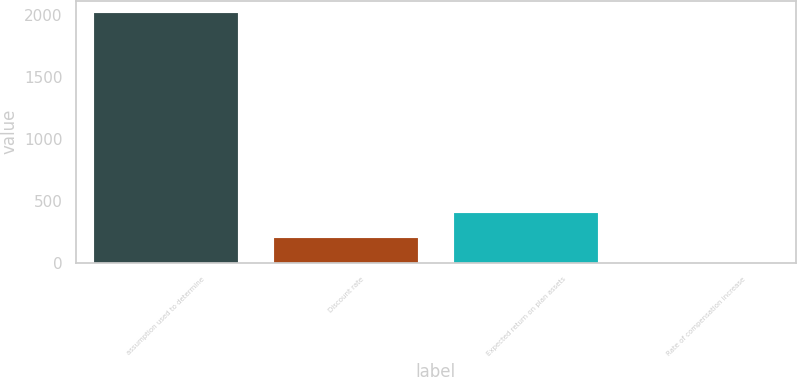Convert chart. <chart><loc_0><loc_0><loc_500><loc_500><bar_chart><fcel>assumption used to determine<fcel>Discount rate<fcel>Expected return on plan assets<fcel>Rate of compensation increase<nl><fcel>2015<fcel>203.3<fcel>404.6<fcel>2<nl></chart> 